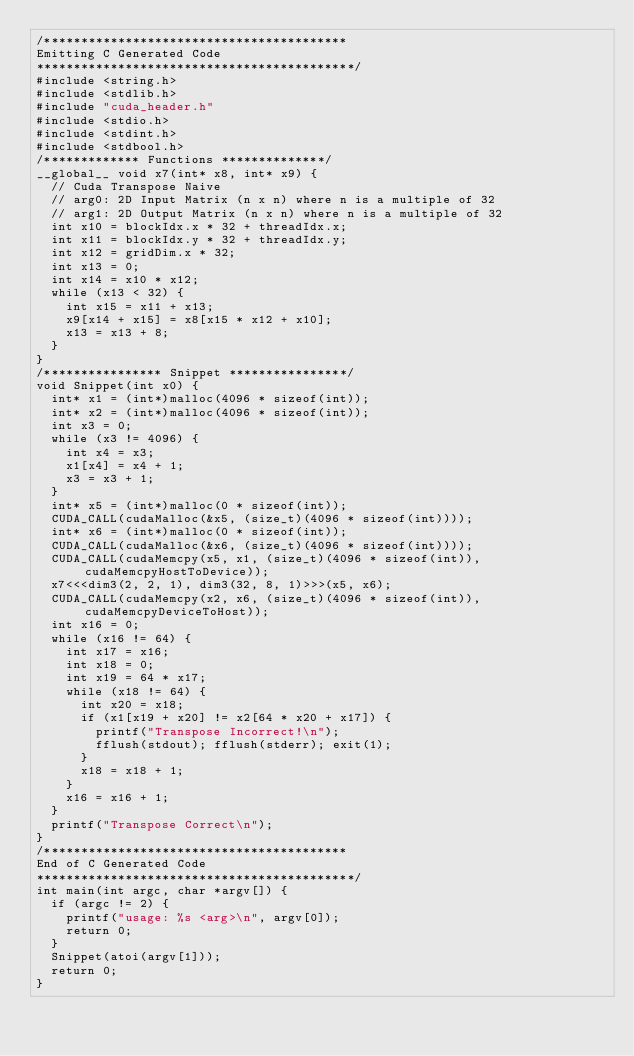<code> <loc_0><loc_0><loc_500><loc_500><_Cuda_>/*****************************************
Emitting C Generated Code
*******************************************/
#include <string.h>
#include <stdlib.h>
#include "cuda_header.h"
#include <stdio.h>
#include <stdint.h>
#include <stdbool.h>
/************* Functions **************/
__global__ void x7(int* x8, int* x9) {
  // Cuda Transpose Naive
  // arg0: 2D Input Matrix (n x n) where n is a multiple of 32
  // arg1: 2D Output Matrix (n x n) where n is a multiple of 32
  int x10 = blockIdx.x * 32 + threadIdx.x;
  int x11 = blockIdx.y * 32 + threadIdx.y;
  int x12 = gridDim.x * 32;
  int x13 = 0;
  int x14 = x10 * x12;
  while (x13 < 32) {
    int x15 = x11 + x13;
    x9[x14 + x15] = x8[x15 * x12 + x10];
    x13 = x13 + 8;
  }
}
/**************** Snippet ****************/
void Snippet(int x0) {
  int* x1 = (int*)malloc(4096 * sizeof(int));
  int* x2 = (int*)malloc(4096 * sizeof(int));
  int x3 = 0;
  while (x3 != 4096) {
    int x4 = x3;
    x1[x4] = x4 + 1;
    x3 = x3 + 1;
  }
  int* x5 = (int*)malloc(0 * sizeof(int));
  CUDA_CALL(cudaMalloc(&x5, (size_t)(4096 * sizeof(int))));
  int* x6 = (int*)malloc(0 * sizeof(int));
  CUDA_CALL(cudaMalloc(&x6, (size_t)(4096 * sizeof(int))));
  CUDA_CALL(cudaMemcpy(x5, x1, (size_t)(4096 * sizeof(int)), cudaMemcpyHostToDevice));
  x7<<<dim3(2, 2, 1), dim3(32, 8, 1)>>>(x5, x6);
  CUDA_CALL(cudaMemcpy(x2, x6, (size_t)(4096 * sizeof(int)), cudaMemcpyDeviceToHost));
  int x16 = 0;
  while (x16 != 64) {
    int x17 = x16;
    int x18 = 0;
    int x19 = 64 * x17;
    while (x18 != 64) {
      int x20 = x18;
      if (x1[x19 + x20] != x2[64 * x20 + x17]) {
        printf("Transpose Incorrect!\n");
        fflush(stdout); fflush(stderr); exit(1);
      }
      x18 = x18 + 1;
    }
    x16 = x16 + 1;
  }
  printf("Transpose Correct\n");
}
/*****************************************
End of C Generated Code
*******************************************/
int main(int argc, char *argv[]) {
  if (argc != 2) {
    printf("usage: %s <arg>\n", argv[0]);
    return 0;
  }
  Snippet(atoi(argv[1]));
  return 0;
}
</code> 